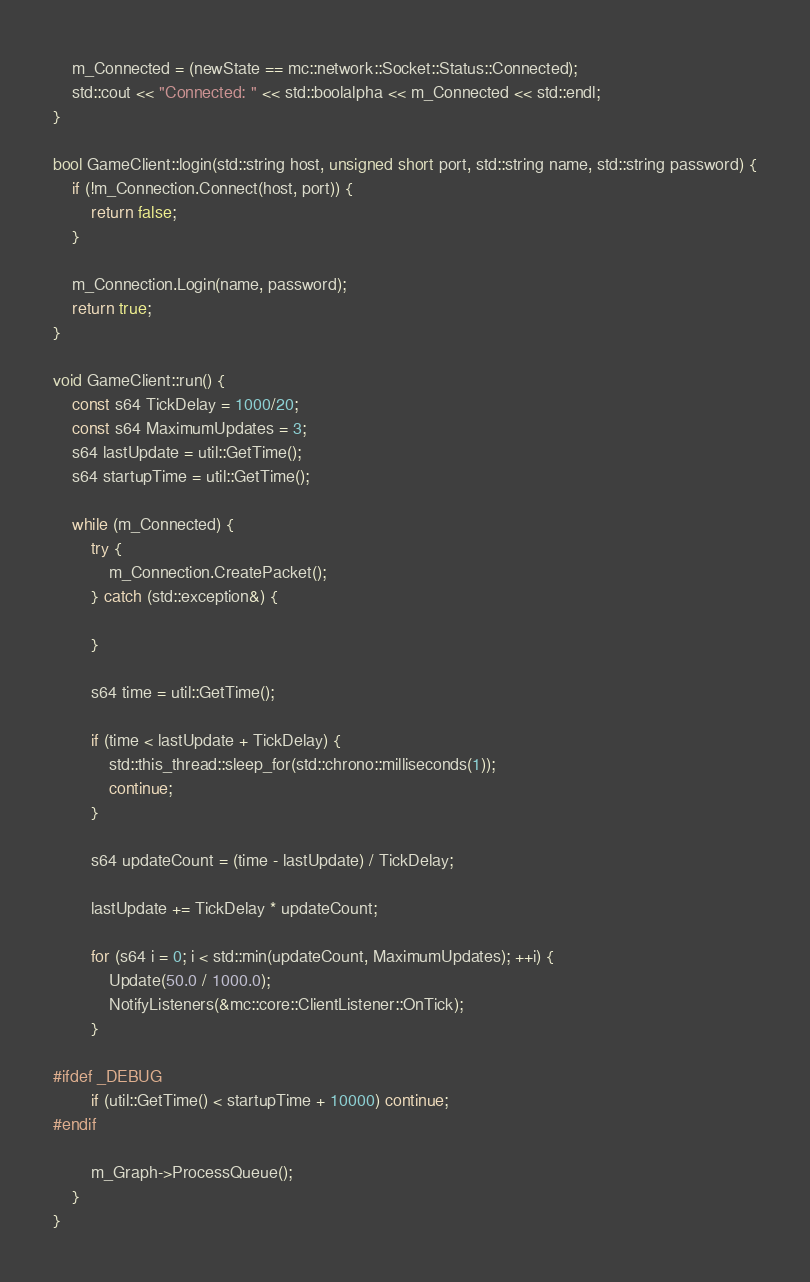Convert code to text. <code><loc_0><loc_0><loc_500><loc_500><_C++_>    m_Connected = (newState == mc::network::Socket::Status::Connected);
    std::cout << "Connected: " << std::boolalpha << m_Connected << std::endl;
}

bool GameClient::login(std::string host, unsigned short port, std::string name, std::string password) {
    if (!m_Connection.Connect(host, port)) {
        return false;
    }

    m_Connection.Login(name, password);
    return true;
}

void GameClient::run() {
    const s64 TickDelay = 1000/20;
    const s64 MaximumUpdates = 3;
    s64 lastUpdate = util::GetTime();
    s64 startupTime = util::GetTime();

    while (m_Connected) {
        try {
            m_Connection.CreatePacket();
        } catch (std::exception&) {

        }

        s64 time = util::GetTime();

        if (time < lastUpdate + TickDelay) {
            std::this_thread::sleep_for(std::chrono::milliseconds(1));
            continue;
        }

        s64 updateCount = (time - lastUpdate) / TickDelay;

        lastUpdate += TickDelay * updateCount;

        for (s64 i = 0; i < std::min(updateCount, MaximumUpdates); ++i) {
            Update(50.0 / 1000.0);
            NotifyListeners(&mc::core::ClientListener::OnTick);
        }

#ifdef _DEBUG
        if (util::GetTime() < startupTime + 10000) continue;
#endif

        m_Graph->ProcessQueue();
    }
}
</code> 